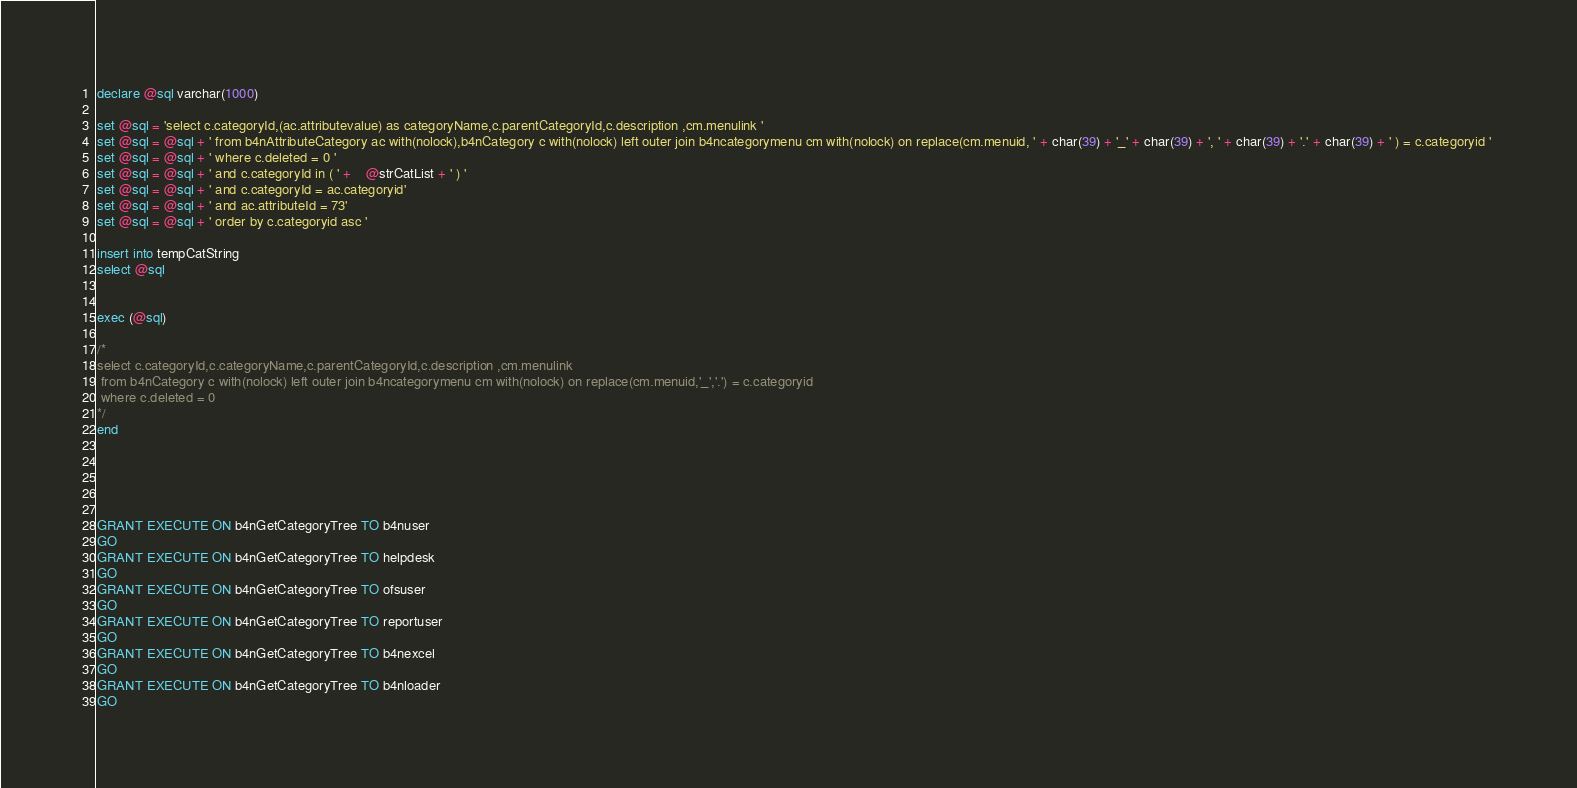<code> <loc_0><loc_0><loc_500><loc_500><_SQL_>declare @sql varchar(1000)

set @sql = 'select c.categoryId,(ac.attributevalue) as categoryName,c.parentCategoryId,c.description ,cm.menulink '
set @sql = @sql + ' from b4nAttributeCategory ac with(nolock),b4nCategory c with(nolock) left outer join b4ncategorymenu cm with(nolock) on replace(cm.menuid, ' + char(39) + '_' + char(39) + ', ' + char(39) + '.' + char(39) + ' ) = c.categoryid ' 
set @sql = @sql + ' where c.deleted = 0 '
set @sql = @sql + ' and c.categoryId in ( ' +    @strCatList + ' ) '
set @sql = @sql + ' and c.categoryId = ac.categoryid'
set @sql = @sql + ' and ac.attributeId = 73'
set @sql = @sql + ' order by c.categoryid asc '

insert into tempCatString
select @sql


exec (@sql)

/*
select c.categoryId,c.categoryName,c.parentCategoryId,c.description ,cm.menulink
 from b4nCategory c with(nolock) left outer join b4ncategorymenu cm with(nolock) on replace(cm.menuid,'_','.') = c.categoryid
 where c.deleted = 0  
*/
end





GRANT EXECUTE ON b4nGetCategoryTree TO b4nuser
GO
GRANT EXECUTE ON b4nGetCategoryTree TO helpdesk
GO
GRANT EXECUTE ON b4nGetCategoryTree TO ofsuser
GO
GRANT EXECUTE ON b4nGetCategoryTree TO reportuser
GO
GRANT EXECUTE ON b4nGetCategoryTree TO b4nexcel
GO
GRANT EXECUTE ON b4nGetCategoryTree TO b4nloader
GO
</code> 